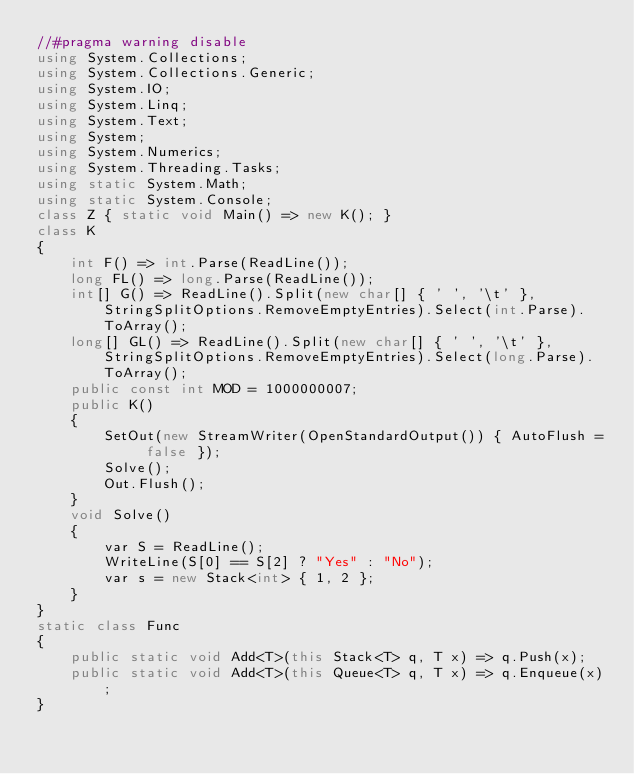<code> <loc_0><loc_0><loc_500><loc_500><_C#_>//#pragma warning disable
using System.Collections;
using System.Collections.Generic;
using System.IO;
using System.Linq;
using System.Text;
using System;
using System.Numerics;
using System.Threading.Tasks;
using static System.Math;
using static System.Console;
class Z { static void Main() => new K(); }
class K
{
	int F() => int.Parse(ReadLine());
	long FL() => long.Parse(ReadLine());
	int[] G() => ReadLine().Split(new char[] { ' ', '\t' }, StringSplitOptions.RemoveEmptyEntries).Select(int.Parse).ToArray();
	long[] GL() => ReadLine().Split(new char[] { ' ', '\t' }, StringSplitOptions.RemoveEmptyEntries).Select(long.Parse).ToArray();
	public const int MOD = 1000000007;
	public K()
	{
		SetOut(new StreamWriter(OpenStandardOutput()) { AutoFlush = false });
		Solve();
		Out.Flush();
	}
	void Solve()
	{
		var S = ReadLine();
		WriteLine(S[0] == S[2] ? "Yes" : "No");
		var s = new Stack<int> { 1, 2 };
	}
}
static class Func
{
	public static void Add<T>(this Stack<T> q, T x) => q.Push(x);
	public static void Add<T>(this Queue<T> q, T x) => q.Enqueue(x);
}</code> 